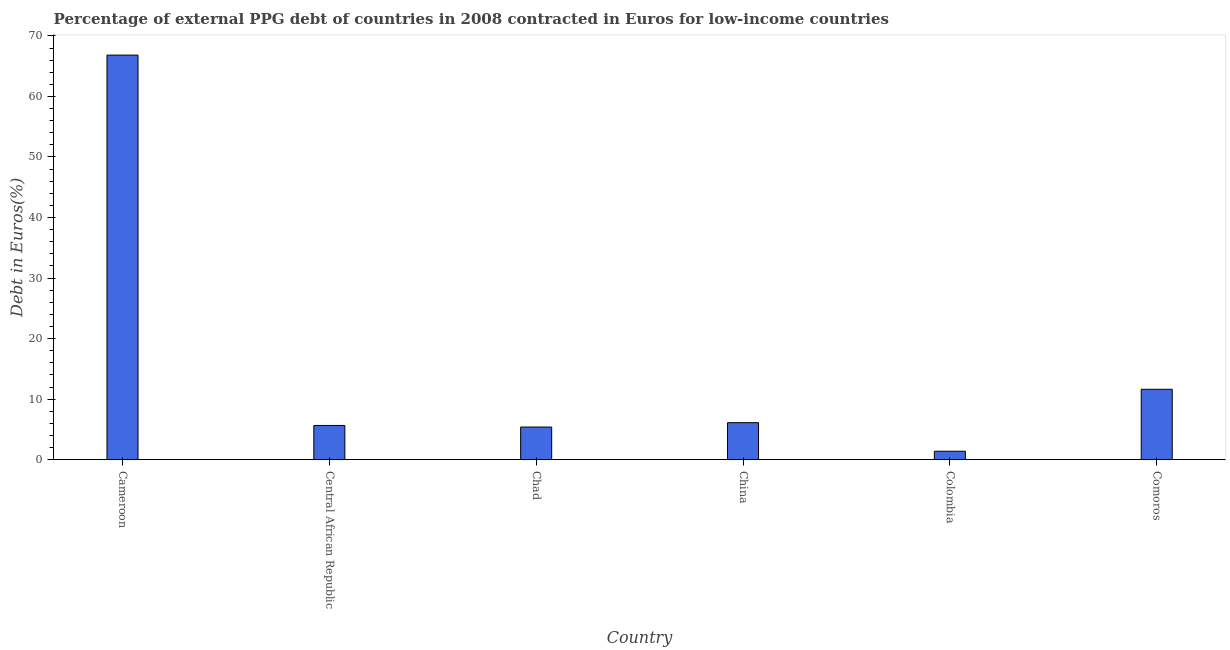What is the title of the graph?
Ensure brevity in your answer.  Percentage of external PPG debt of countries in 2008 contracted in Euros for low-income countries. What is the label or title of the Y-axis?
Offer a terse response. Debt in Euros(%). What is the currency composition of ppg debt in Central African Republic?
Your answer should be very brief. 5.66. Across all countries, what is the maximum currency composition of ppg debt?
Offer a terse response. 66.83. Across all countries, what is the minimum currency composition of ppg debt?
Offer a terse response. 1.4. In which country was the currency composition of ppg debt maximum?
Make the answer very short. Cameroon. What is the sum of the currency composition of ppg debt?
Your answer should be very brief. 97.02. What is the difference between the currency composition of ppg debt in Central African Republic and Colombia?
Your answer should be very brief. 4.26. What is the average currency composition of ppg debt per country?
Your answer should be very brief. 16.17. What is the median currency composition of ppg debt?
Ensure brevity in your answer.  5.89. What is the ratio of the currency composition of ppg debt in Cameroon to that in China?
Offer a terse response. 10.93. Is the currency composition of ppg debt in Cameroon less than that in China?
Your answer should be very brief. No. What is the difference between the highest and the second highest currency composition of ppg debt?
Give a very brief answer. 55.2. Is the sum of the currency composition of ppg debt in Central African Republic and Chad greater than the maximum currency composition of ppg debt across all countries?
Offer a very short reply. No. What is the difference between the highest and the lowest currency composition of ppg debt?
Offer a terse response. 65.43. How many countries are there in the graph?
Make the answer very short. 6. What is the Debt in Euros(%) of Cameroon?
Give a very brief answer. 66.83. What is the Debt in Euros(%) of Central African Republic?
Keep it short and to the point. 5.66. What is the Debt in Euros(%) in Chad?
Provide a short and direct response. 5.39. What is the Debt in Euros(%) of China?
Offer a very short reply. 6.11. What is the Debt in Euros(%) of Colombia?
Make the answer very short. 1.4. What is the Debt in Euros(%) in Comoros?
Give a very brief answer. 11.63. What is the difference between the Debt in Euros(%) in Cameroon and Central African Republic?
Provide a short and direct response. 61.17. What is the difference between the Debt in Euros(%) in Cameroon and Chad?
Your answer should be very brief. 61.43. What is the difference between the Debt in Euros(%) in Cameroon and China?
Provide a succinct answer. 60.71. What is the difference between the Debt in Euros(%) in Cameroon and Colombia?
Make the answer very short. 65.43. What is the difference between the Debt in Euros(%) in Cameroon and Comoros?
Offer a terse response. 55.19. What is the difference between the Debt in Euros(%) in Central African Republic and Chad?
Provide a succinct answer. 0.26. What is the difference between the Debt in Euros(%) in Central African Republic and China?
Your response must be concise. -0.46. What is the difference between the Debt in Euros(%) in Central African Republic and Colombia?
Your answer should be compact. 4.26. What is the difference between the Debt in Euros(%) in Central African Republic and Comoros?
Provide a short and direct response. -5.98. What is the difference between the Debt in Euros(%) in Chad and China?
Give a very brief answer. -0.72. What is the difference between the Debt in Euros(%) in Chad and Colombia?
Your response must be concise. 4. What is the difference between the Debt in Euros(%) in Chad and Comoros?
Give a very brief answer. -6.24. What is the difference between the Debt in Euros(%) in China and Colombia?
Keep it short and to the point. 4.72. What is the difference between the Debt in Euros(%) in China and Comoros?
Ensure brevity in your answer.  -5.52. What is the difference between the Debt in Euros(%) in Colombia and Comoros?
Ensure brevity in your answer.  -10.23. What is the ratio of the Debt in Euros(%) in Cameroon to that in Central African Republic?
Give a very brief answer. 11.81. What is the ratio of the Debt in Euros(%) in Cameroon to that in Chad?
Ensure brevity in your answer.  12.39. What is the ratio of the Debt in Euros(%) in Cameroon to that in China?
Your answer should be compact. 10.93. What is the ratio of the Debt in Euros(%) in Cameroon to that in Colombia?
Keep it short and to the point. 47.78. What is the ratio of the Debt in Euros(%) in Cameroon to that in Comoros?
Provide a succinct answer. 5.75. What is the ratio of the Debt in Euros(%) in Central African Republic to that in Chad?
Provide a succinct answer. 1.05. What is the ratio of the Debt in Euros(%) in Central African Republic to that in China?
Offer a very short reply. 0.93. What is the ratio of the Debt in Euros(%) in Central African Republic to that in Colombia?
Your response must be concise. 4.04. What is the ratio of the Debt in Euros(%) in Central African Republic to that in Comoros?
Offer a terse response. 0.49. What is the ratio of the Debt in Euros(%) in Chad to that in China?
Provide a succinct answer. 0.88. What is the ratio of the Debt in Euros(%) in Chad to that in Colombia?
Provide a short and direct response. 3.86. What is the ratio of the Debt in Euros(%) in Chad to that in Comoros?
Provide a short and direct response. 0.46. What is the ratio of the Debt in Euros(%) in China to that in Colombia?
Ensure brevity in your answer.  4.37. What is the ratio of the Debt in Euros(%) in China to that in Comoros?
Your response must be concise. 0.53. What is the ratio of the Debt in Euros(%) in Colombia to that in Comoros?
Ensure brevity in your answer.  0.12. 